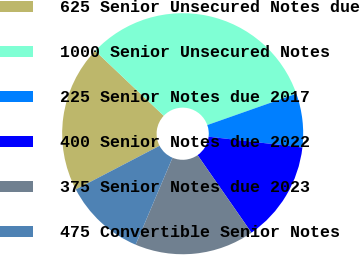Convert chart. <chart><loc_0><loc_0><loc_500><loc_500><pie_chart><fcel>625 Senior Unsecured Notes due<fcel>1000 Senior Unsecured Notes<fcel>225 Senior Notes due 2017<fcel>400 Senior Notes due 2022<fcel>375 Senior Notes due 2023<fcel>475 Convertible Senior Notes<nl><fcel>19.72%<fcel>32.54%<fcel>7.21%<fcel>13.51%<fcel>16.05%<fcel>10.97%<nl></chart> 